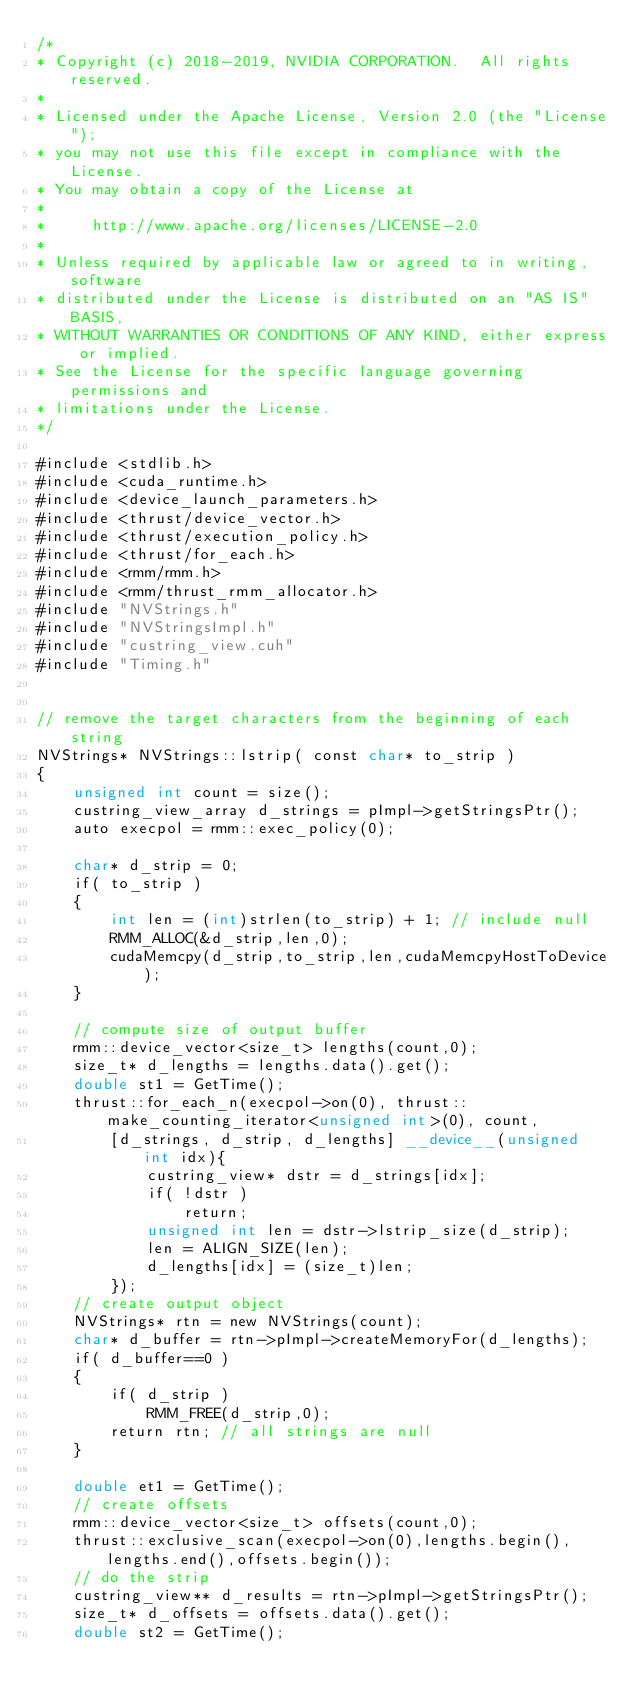Convert code to text. <code><loc_0><loc_0><loc_500><loc_500><_Cuda_>/*
* Copyright (c) 2018-2019, NVIDIA CORPORATION.  All rights reserved.
*
* Licensed under the Apache License, Version 2.0 (the "License");
* you may not use this file except in compliance with the License.
* You may obtain a copy of the License at
*
*     http://www.apache.org/licenses/LICENSE-2.0
*
* Unless required by applicable law or agreed to in writing, software
* distributed under the License is distributed on an "AS IS" BASIS,
* WITHOUT WARRANTIES OR CONDITIONS OF ANY KIND, either express or implied.
* See the License for the specific language governing permissions and
* limitations under the License.
*/

#include <stdlib.h>
#include <cuda_runtime.h>
#include <device_launch_parameters.h>
#include <thrust/device_vector.h>
#include <thrust/execution_policy.h>
#include <thrust/for_each.h>
#include <rmm/rmm.h>
#include <rmm/thrust_rmm_allocator.h>
#include "NVStrings.h"
#include "NVStringsImpl.h"
#include "custring_view.cuh"
#include "Timing.h"


// remove the target characters from the beginning of each string
NVStrings* NVStrings::lstrip( const char* to_strip )
{
    unsigned int count = size();
    custring_view_array d_strings = pImpl->getStringsPtr();
    auto execpol = rmm::exec_policy(0);

    char* d_strip = 0;
    if( to_strip )
    {
        int len = (int)strlen(to_strip) + 1; // include null
        RMM_ALLOC(&d_strip,len,0);
        cudaMemcpy(d_strip,to_strip,len,cudaMemcpyHostToDevice);
    }

    // compute size of output buffer
    rmm::device_vector<size_t> lengths(count,0);
    size_t* d_lengths = lengths.data().get();
    double st1 = GetTime();
    thrust::for_each_n(execpol->on(0), thrust::make_counting_iterator<unsigned int>(0), count,
        [d_strings, d_strip, d_lengths] __device__(unsigned int idx){
            custring_view* dstr = d_strings[idx];
            if( !dstr )
                return;
            unsigned int len = dstr->lstrip_size(d_strip);
            len = ALIGN_SIZE(len);
            d_lengths[idx] = (size_t)len;
        });
    // create output object
    NVStrings* rtn = new NVStrings(count);
    char* d_buffer = rtn->pImpl->createMemoryFor(d_lengths);
    if( d_buffer==0 )
    {
        if( d_strip )
            RMM_FREE(d_strip,0);
        return rtn; // all strings are null
    }

    double et1 = GetTime();
    // create offsets
    rmm::device_vector<size_t> offsets(count,0);
    thrust::exclusive_scan(execpol->on(0),lengths.begin(),lengths.end(),offsets.begin());
    // do the strip
    custring_view** d_results = rtn->pImpl->getStringsPtr();
    size_t* d_offsets = offsets.data().get();
    double st2 = GetTime();</code> 